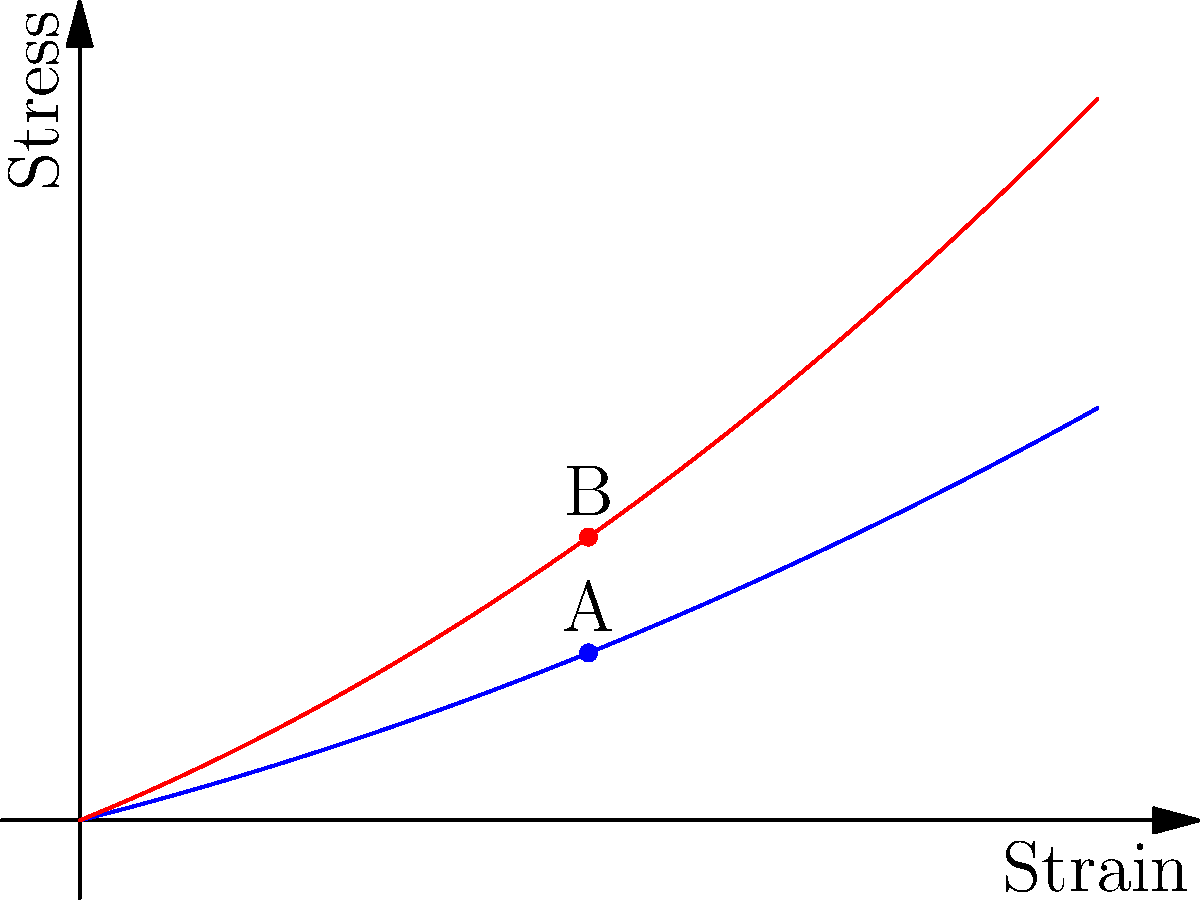Based on the stress-strain curves shown for normal breast tissue (blue) and cancerous breast tissue (red), which of the following statements is correct regarding the mechanical properties of these tissues at point A (normal tissue) and point B (cancerous tissue)?

a) Cancerous tissue is more compliant than normal tissue
b) Normal tissue has a higher elastic modulus than cancerous tissue
c) Cancerous tissue has a higher elastic modulus than normal tissue
d) Both tissues have the same stiffness at the given strain To answer this question, we need to analyze the stress-strain curves and understand the concept of elastic modulus:

1. The elastic modulus is a measure of a material's stiffness, defined as the ratio of stress to strain in the linear elastic region.

2. In stress-strain curves, a steeper slope indicates a higher elastic modulus and thus higher stiffness.

3. Comparing the two curves at points A and B (same strain level):
   - The cancerous tissue (red curve) shows higher stress for the same strain.
   - The slope of the tangent line at point B is steeper than at point A.

4. A steeper slope in the stress-strain curve indicates a higher elastic modulus:
   $$E = \frac{\Delta \sigma}{\Delta \epsilon}$$
   where $E$ is the elastic modulus, $\sigma$ is stress, and $\epsilon$ is strain.

5. The higher stress and steeper slope for cancerous tissue indicate that it has a higher elastic modulus and is therefore stiffer than normal tissue.

6. Compliance is the inverse of stiffness, so cancerous tissue is less compliant than normal tissue.

Therefore, the correct statement is that cancerous tissue has a higher elastic modulus than normal tissue.
Answer: c) Cancerous tissue has a higher elastic modulus than normal tissue 